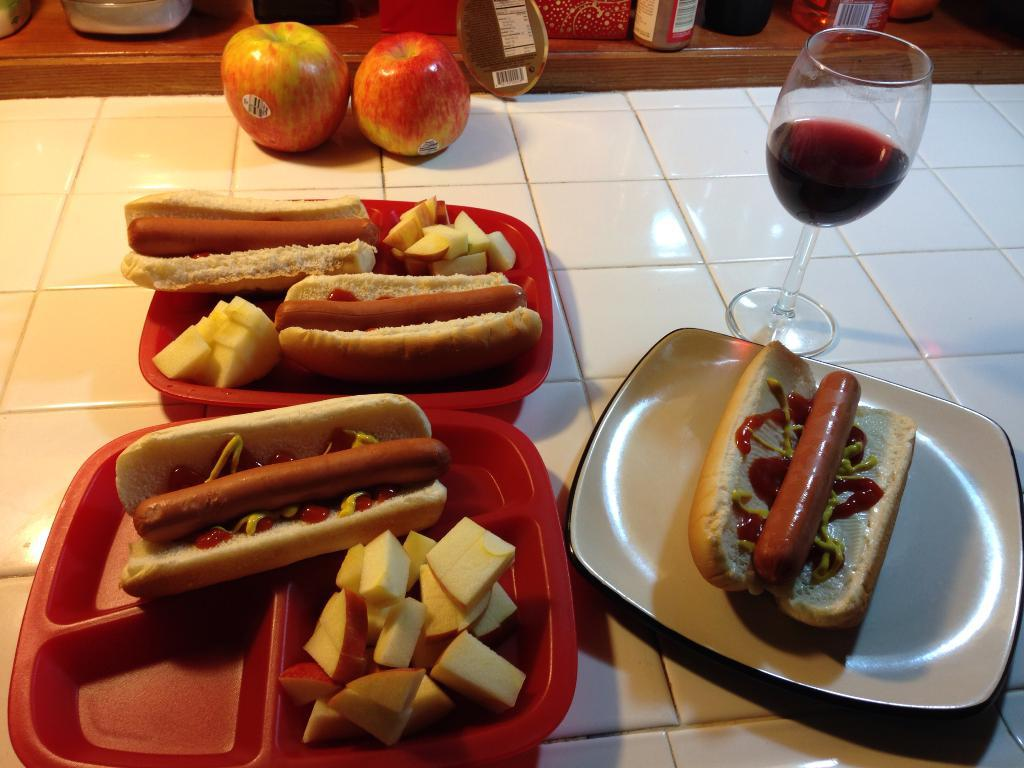What is on the plate in the image? There are food items on a plate in the image. What is in the glass that is visible in the image? There is a glass of drink in the image. How many apples can be seen in the image? There are two apples in the image. What type of containers are present in the image? There are jars and boxes in the image. What material is the surface that the food items are placed on? The wooden surface is present in the image. Can you tell me how many errors the donkey made while trying to open the tank in the image? There is no donkey or tank present in the image, so this question cannot be answered. 